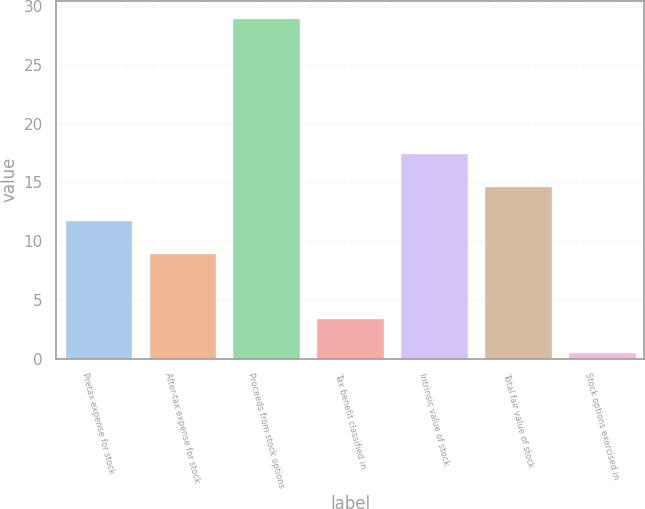Convert chart to OTSL. <chart><loc_0><loc_0><loc_500><loc_500><bar_chart><fcel>Pretax expense for stock<fcel>After-tax expense for stock<fcel>Proceeds from stock options<fcel>Tax benefit classified in<fcel>Intrinsic value of stock<fcel>Total fair value of stock<fcel>Stock options exercised in<nl><fcel>11.84<fcel>9<fcel>29<fcel>3.44<fcel>17.52<fcel>14.68<fcel>0.6<nl></chart> 